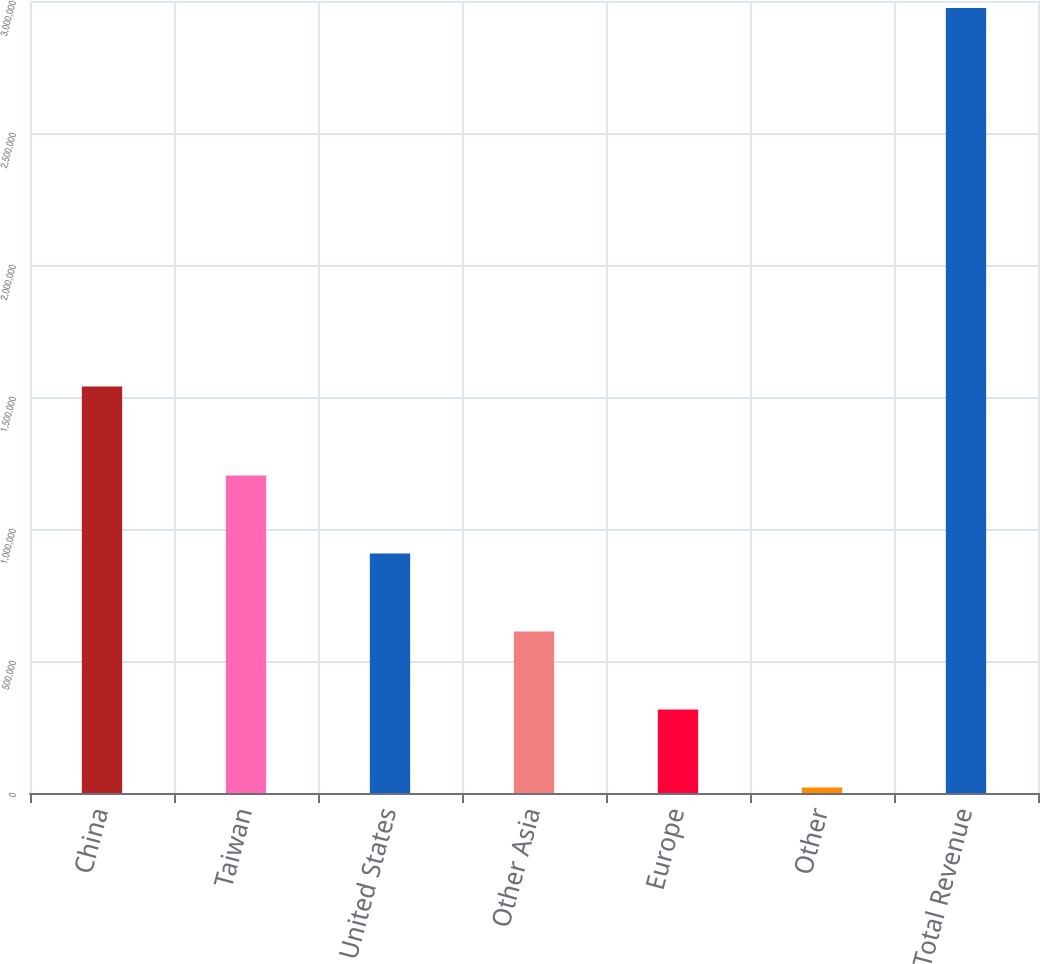Convert chart. <chart><loc_0><loc_0><loc_500><loc_500><bar_chart><fcel>China<fcel>Taiwan<fcel>United States<fcel>Other Asia<fcel>Europe<fcel>Other<fcel>Total Revenue<nl><fcel>1.53973e+06<fcel>1.20218e+06<fcel>906958<fcel>611732<fcel>316506<fcel>21281<fcel>2.97354e+06<nl></chart> 